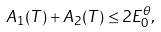<formula> <loc_0><loc_0><loc_500><loc_500>A _ { 1 } ( T ) + A _ { 2 } ( T ) \leq 2 E _ { 0 } ^ { \theta } ,</formula> 